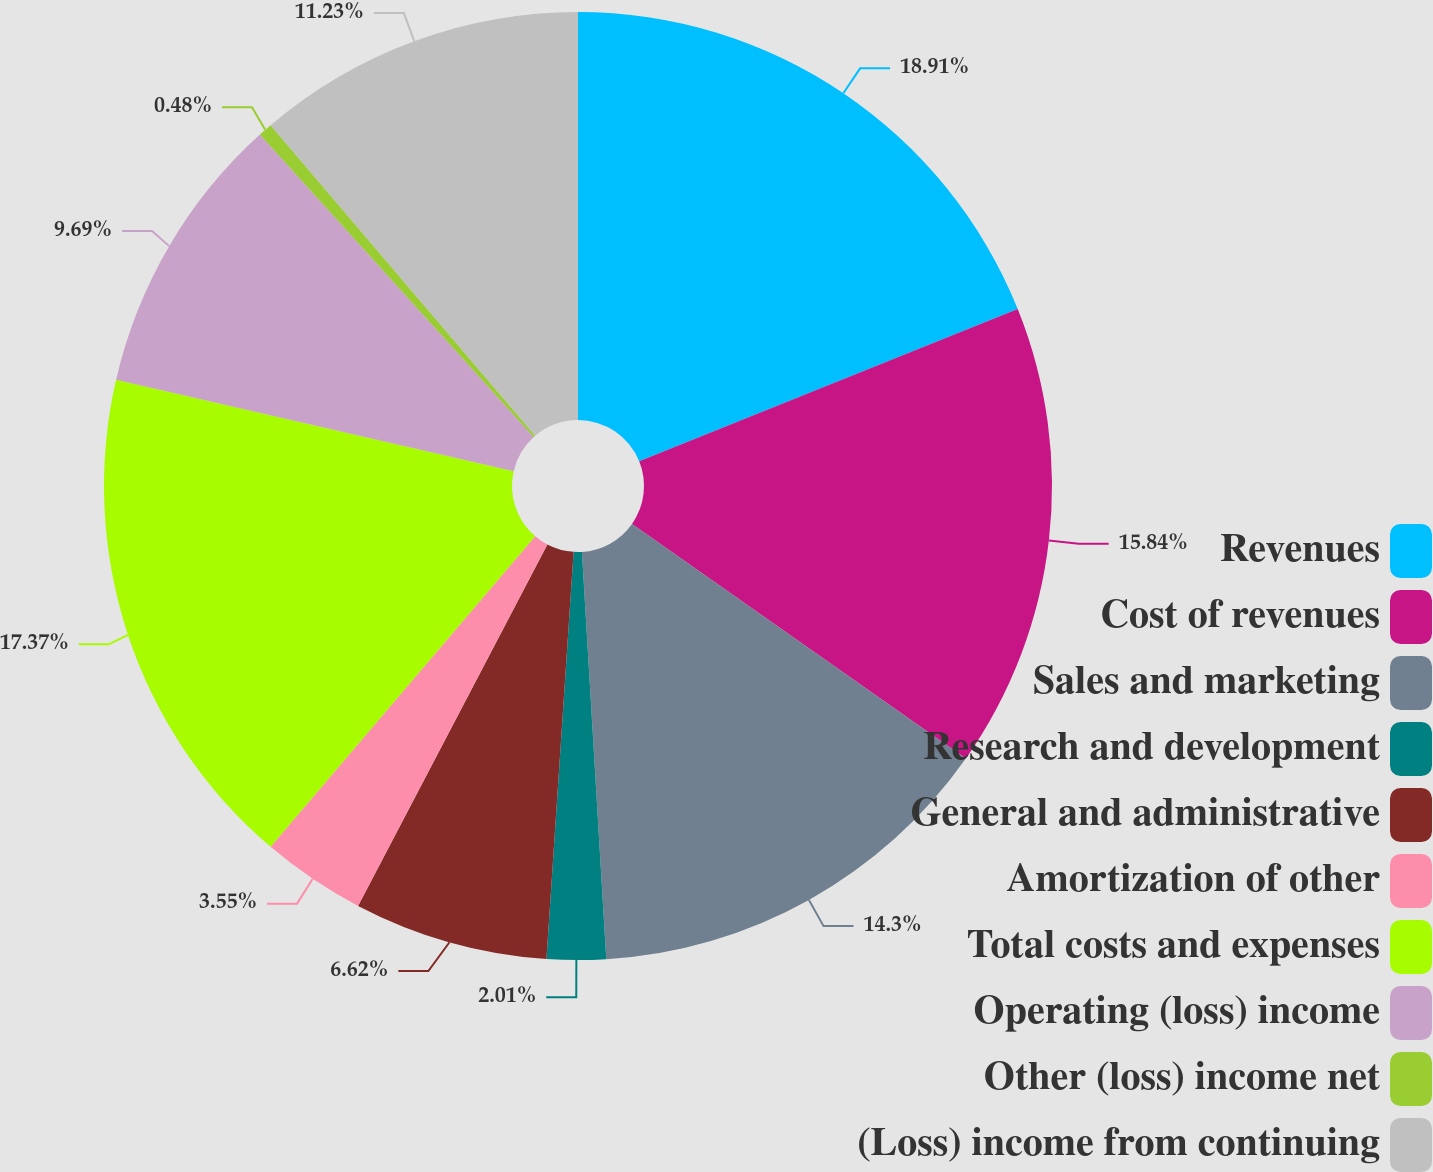Convert chart. <chart><loc_0><loc_0><loc_500><loc_500><pie_chart><fcel>Revenues<fcel>Cost of revenues<fcel>Sales and marketing<fcel>Research and development<fcel>General and administrative<fcel>Amortization of other<fcel>Total costs and expenses<fcel>Operating (loss) income<fcel>Other (loss) income net<fcel>(Loss) income from continuing<nl><fcel>18.91%<fcel>15.84%<fcel>14.3%<fcel>2.01%<fcel>6.62%<fcel>3.55%<fcel>17.37%<fcel>9.69%<fcel>0.48%<fcel>11.23%<nl></chart> 